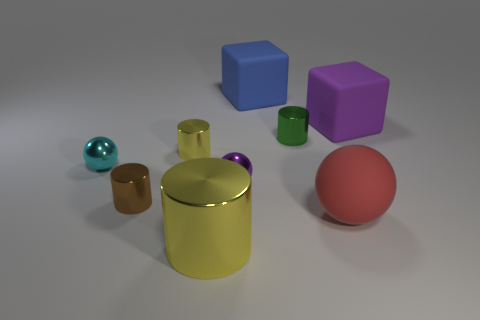Subtract 1 cylinders. How many cylinders are left? 3 Add 1 big metallic balls. How many objects exist? 10 Subtract all cubes. How many objects are left? 7 Subtract 0 yellow balls. How many objects are left? 9 Subtract all red metal things. Subtract all blue matte things. How many objects are left? 8 Add 7 metal balls. How many metal balls are left? 9 Add 6 blue rubber cubes. How many blue rubber cubes exist? 7 